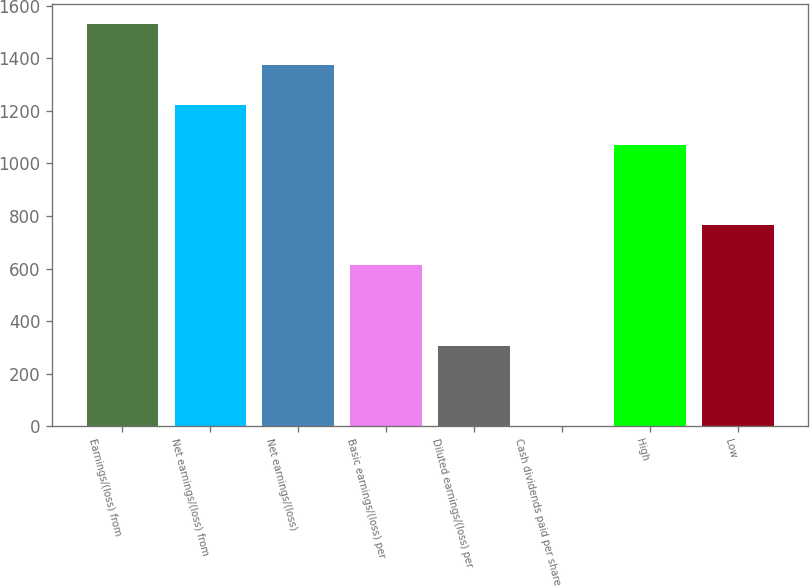Convert chart to OTSL. <chart><loc_0><loc_0><loc_500><loc_500><bar_chart><fcel>Earnings/(loss) from<fcel>Net earnings/(loss) from<fcel>Net earnings/(loss)<fcel>Basic earnings/(loss) per<fcel>Diluted earnings/(loss) per<fcel>Cash dividends paid per share<fcel>High<fcel>Low<nl><fcel>1529.02<fcel>1223.3<fcel>1376.16<fcel>611.86<fcel>306.14<fcel>0.42<fcel>1070.44<fcel>764.72<nl></chart> 